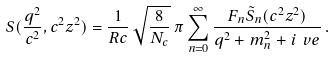<formula> <loc_0><loc_0><loc_500><loc_500>S ( \frac { q ^ { 2 } } { c ^ { 2 } } , c ^ { 2 } z ^ { 2 } ) = \frac { 1 } { R c } \, \sqrt { \frac { 8 } { N _ { c } } } \, \pi \sum _ { n = 0 } ^ { \infty } \frac { F _ { n } \tilde { S } _ { n } ( c ^ { 2 } z ^ { 2 } ) } { q ^ { 2 } + m _ { n } ^ { 2 } + i \ v e } \, .</formula> 